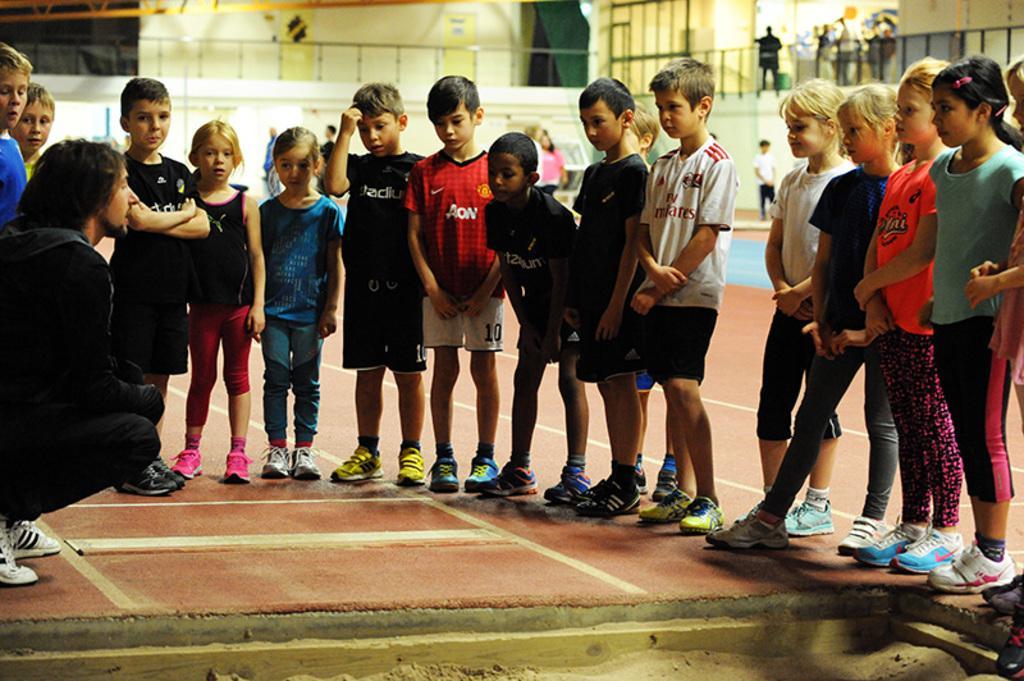Can you describe this image briefly? In this image I see number of kids and a man over here and I see the path. In the background I see few more people and I see the fencing over here and I see the wall and I can also see white lines on the floor. 